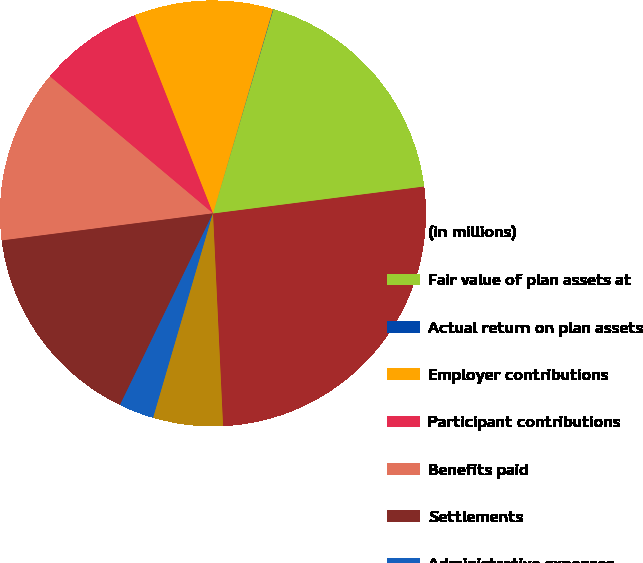<chart> <loc_0><loc_0><loc_500><loc_500><pie_chart><fcel>(in millions)<fcel>Fair value of plan assets at<fcel>Actual return on plan assets<fcel>Employer contributions<fcel>Participant contributions<fcel>Benefits paid<fcel>Settlements<fcel>Administrative expenses<fcel>Foreign currency translation<nl><fcel>26.27%<fcel>18.4%<fcel>0.03%<fcel>10.53%<fcel>7.9%<fcel>13.15%<fcel>15.78%<fcel>2.66%<fcel>5.28%<nl></chart> 